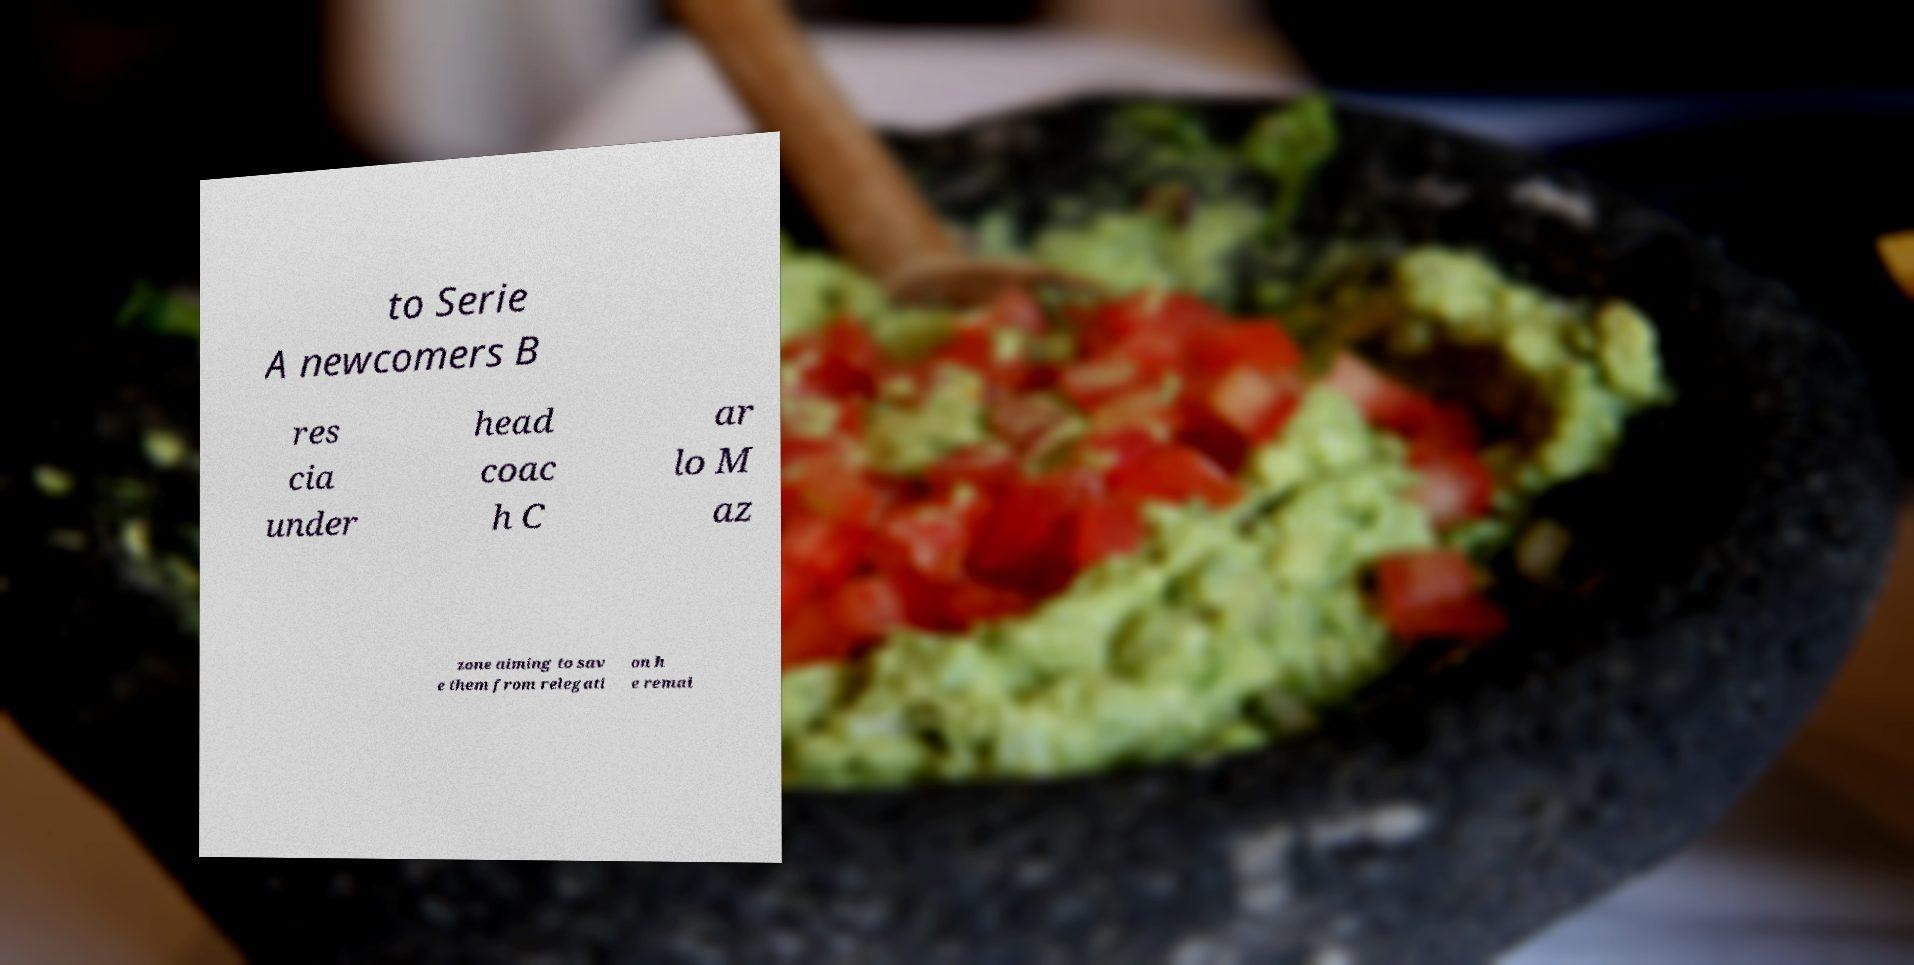For documentation purposes, I need the text within this image transcribed. Could you provide that? to Serie A newcomers B res cia under head coac h C ar lo M az zone aiming to sav e them from relegati on h e remai 